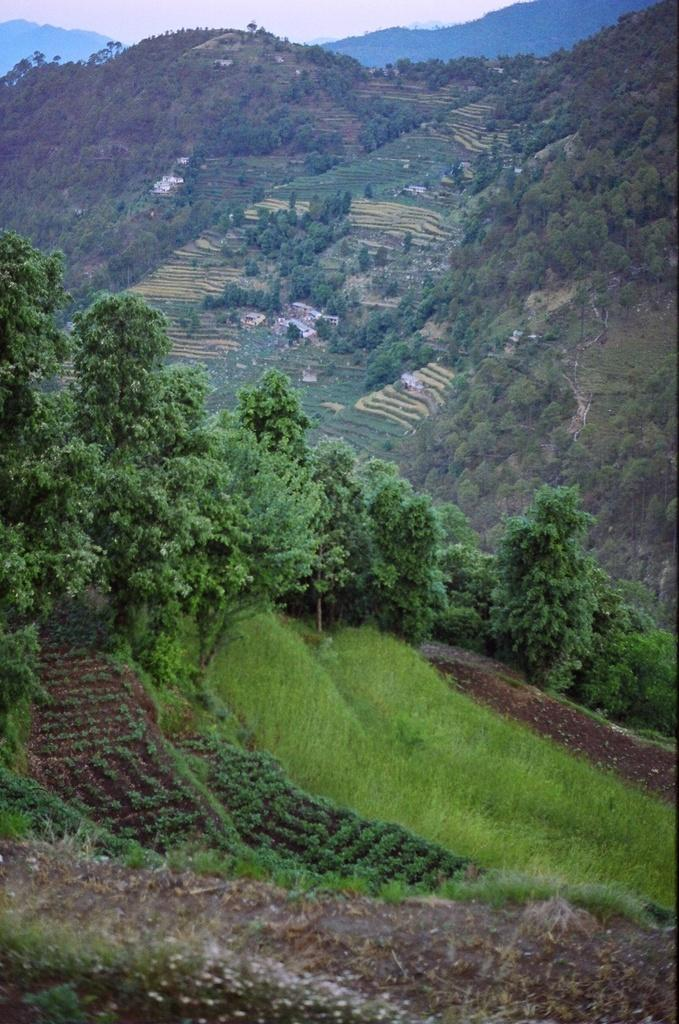What type of natural elements can be seen in the image? There is a group of trees in the image. What type of man-made structures are present in the image? There are buildings in the image. What geographical features can be observed in the image? There are hills visible in the image. Where is the playground located in the image? There is no playground present in the image. What type of park can be seen in the image? There is no park present in the image. 